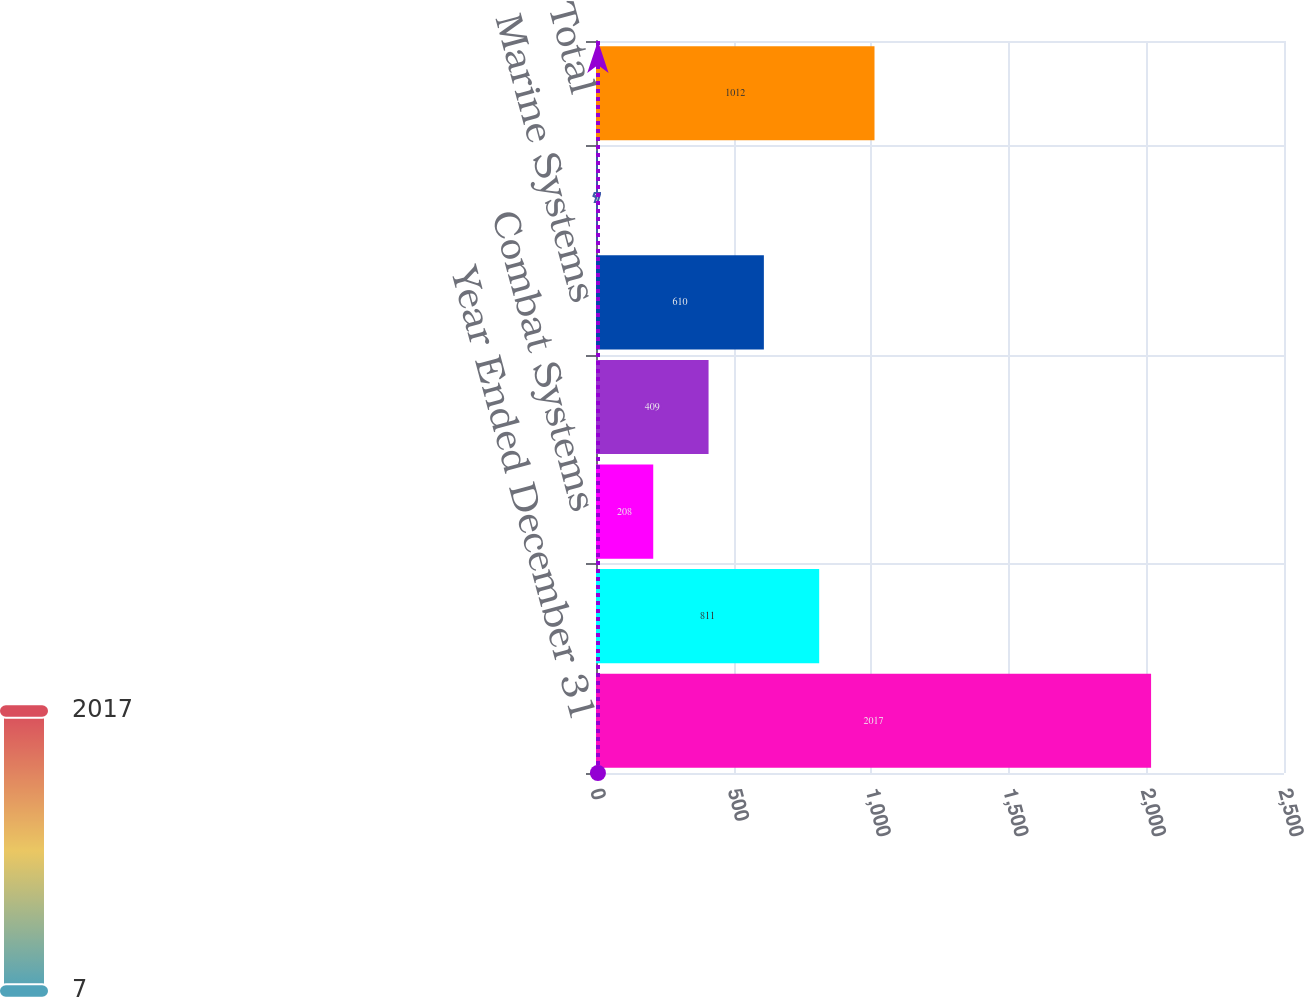<chart> <loc_0><loc_0><loc_500><loc_500><bar_chart><fcel>Year Ended December 31<fcel>Aerospace<fcel>Combat Systems<fcel>Information Systems and<fcel>Marine Systems<fcel>Corporate<fcel>Total<nl><fcel>2017<fcel>811<fcel>208<fcel>409<fcel>610<fcel>7<fcel>1012<nl></chart> 